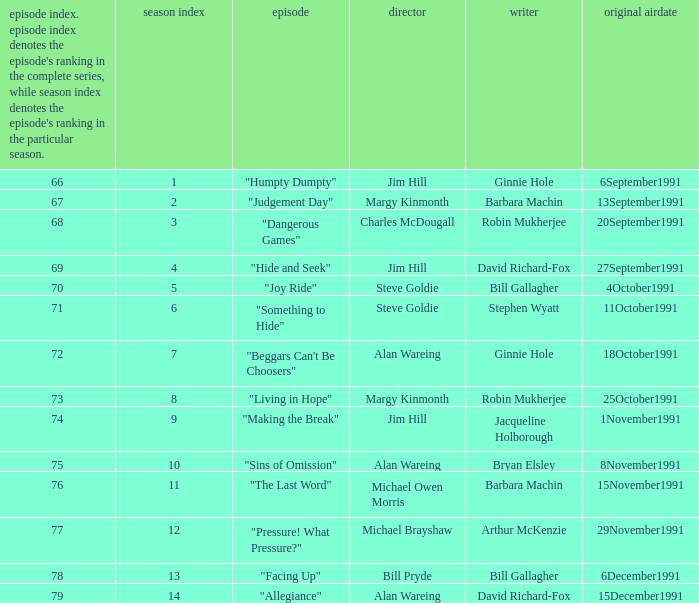Name the original airdate for robin mukherjee and margy kinmonth 25October1991. 